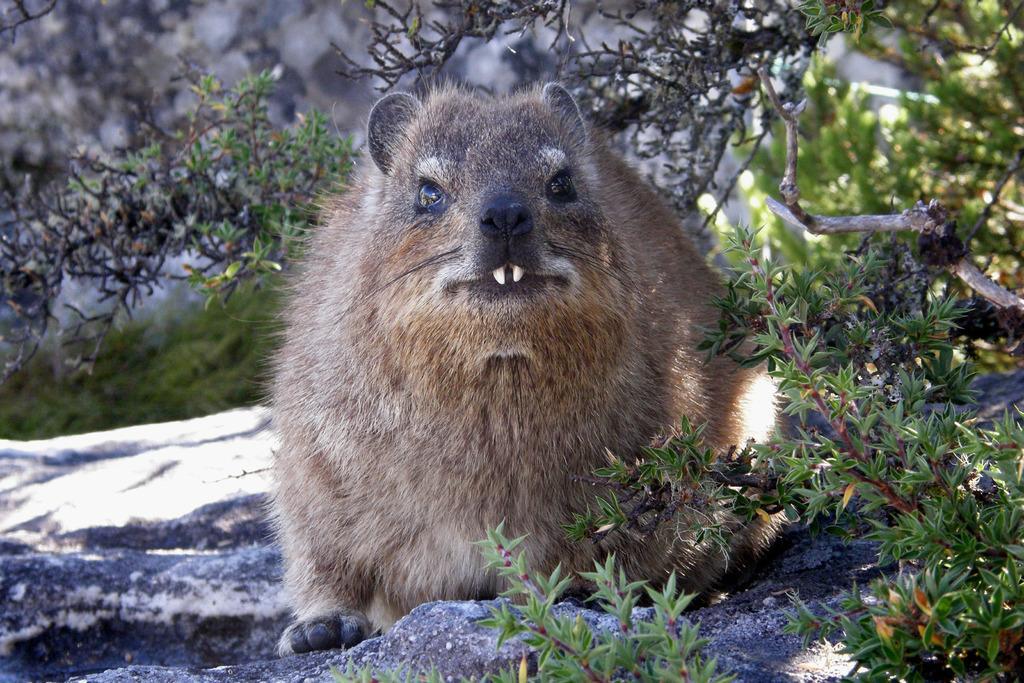Describe this image in one or two sentences. In this image, I can see an animal, which is on the rock. These are the trees with branches and leaves. The background looks blurry. 